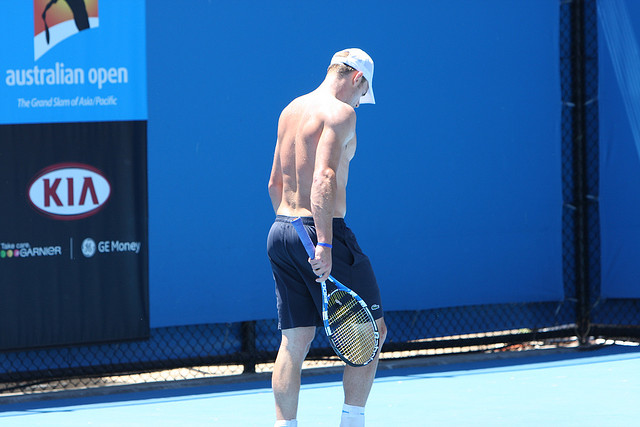Describe the environment in which this tennis player is located. The tennis player is on a well-maintained tennis court with a bright blue surface. The setting appears to be part of a professional or high-profile tennis facility, as indicated by the prominent Australian Open banner on the left side. Behind the player, there is a black netting fence, further hinting at a dedicated sports installation designed to host significant tennis events or practice sessions. The presence of corporate sponsorship banners, such as one from KIA and GE Money, reinforces the professional nature of this setting. Additionally, the clear and bright lighting suggests it is a sunny day, possibly during an outdoor practice or match. 